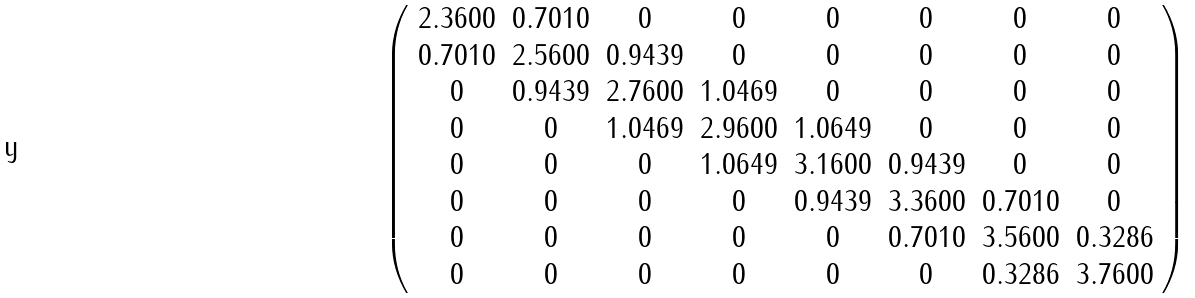<formula> <loc_0><loc_0><loc_500><loc_500>\left ( \begin{array} { c c c c c c c c } 2 . 3 6 0 0 & 0 . 7 0 1 0 & 0 & 0 & 0 & 0 & 0 & 0 \\ 0 . 7 0 1 0 & 2 . 5 6 0 0 & 0 . 9 4 3 9 & 0 & 0 & 0 & 0 & 0 \\ 0 & 0 . 9 4 3 9 & 2 . 7 6 0 0 & 1 . 0 4 6 9 & 0 & 0 & 0 & 0 \\ 0 & 0 & 1 . 0 4 6 9 & 2 . 9 6 0 0 & 1 . 0 6 4 9 & 0 & 0 & 0 \\ 0 & 0 & 0 & 1 . 0 6 4 9 & 3 . 1 6 0 0 & 0 . 9 4 3 9 & 0 & 0 \\ 0 & 0 & 0 & 0 & 0 . 9 4 3 9 & 3 . 3 6 0 0 & 0 . 7 0 1 0 & 0 \\ 0 & 0 & 0 & 0 & 0 & 0 . 7 0 1 0 & 3 . 5 6 0 0 & 0 . 3 2 8 6 \\ 0 & 0 & 0 & 0 & 0 & 0 & 0 . 3 2 8 6 & 3 . 7 6 0 0 \\ \end{array} \right )</formula> 